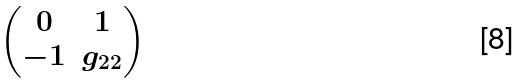Convert formula to latex. <formula><loc_0><loc_0><loc_500><loc_500>\begin{pmatrix} 0 & 1 \\ - 1 & g _ { 2 2 } \end{pmatrix}</formula> 